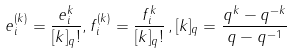<formula> <loc_0><loc_0><loc_500><loc_500>e _ { i } ^ { ( k ) } = \frac { e ^ { k } _ { i } } { [ k ] _ { q } ! } , f ^ { ( k ) } _ { i } = \frac { f ^ { k } _ { i } } { [ k ] _ { q } ! } \, , [ k ] _ { q } = \frac { q ^ { k } - q ^ { - k } } { q - q ^ { - 1 } }</formula> 